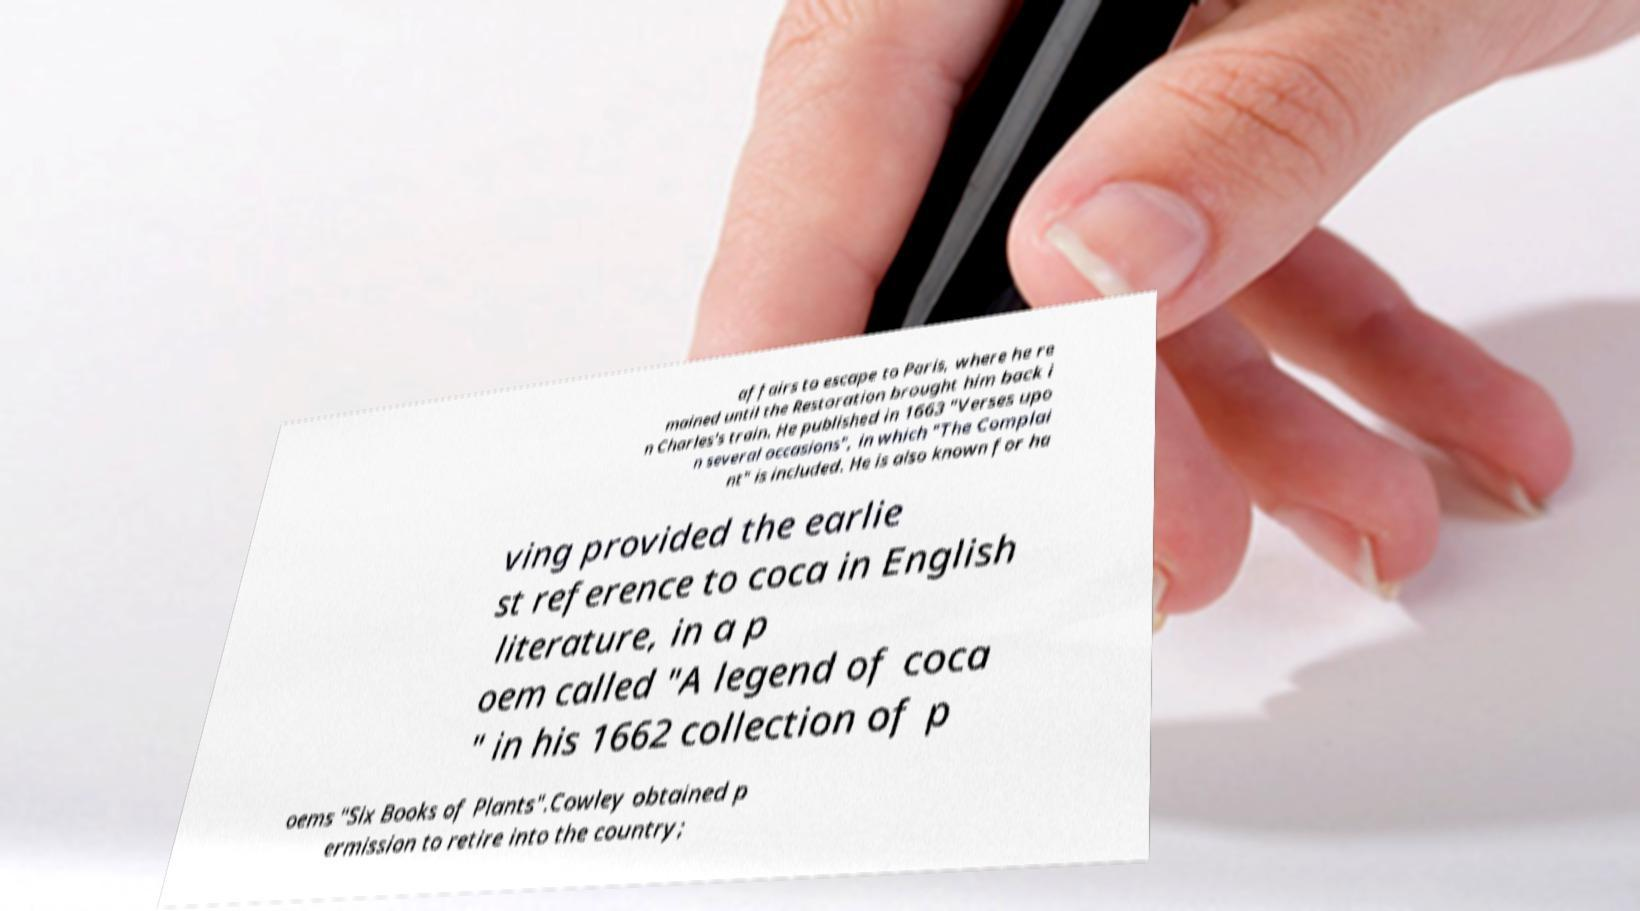Can you accurately transcribe the text from the provided image for me? affairs to escape to Paris, where he re mained until the Restoration brought him back i n Charles's train. He published in 1663 "Verses upo n several occasions", in which "The Complai nt" is included. He is also known for ha ving provided the earlie st reference to coca in English literature, in a p oem called "A legend of coca " in his 1662 collection of p oems "Six Books of Plants".Cowley obtained p ermission to retire into the country; 